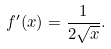Convert formula to latex. <formula><loc_0><loc_0><loc_500><loc_500>f ^ { \prime } ( x ) = { \frac { 1 } { 2 { \sqrt { x } } } } .</formula> 